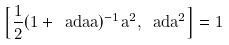Convert formula to latex. <formula><loc_0><loc_0><loc_500><loc_500>\left [ \frac { 1 } { 2 } ( 1 + \ a d { a } a ) ^ { - 1 } a ^ { 2 } , \ a d { a } ^ { 2 } \right ] = 1</formula> 